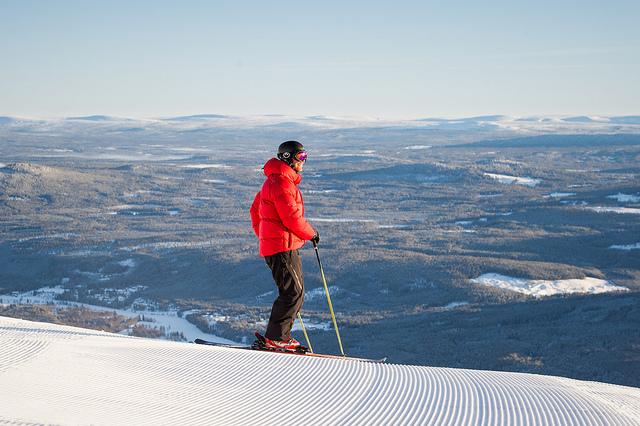What color is the coat?
Quick response, please. Red. What color is the person's helmet?
Short answer required. Black. From where was it taken?
Keep it brief. Mountain. Who took the picture?
Give a very brief answer. Photographer. What sport is this person doing?
Short answer required. Skiing. 